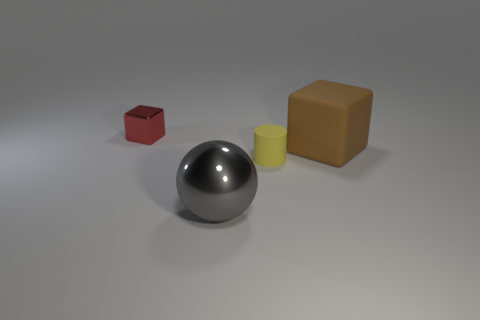Add 3 small cyan matte cylinders. How many objects exist? 7 Subtract all red blocks. How many blocks are left? 1 Subtract all cylinders. How many objects are left? 3 Add 3 big gray objects. How many big gray objects are left? 4 Add 1 blue shiny cylinders. How many blue shiny cylinders exist? 1 Subtract 0 brown cylinders. How many objects are left? 4 Subtract 2 cubes. How many cubes are left? 0 Subtract all purple spheres. Subtract all red cylinders. How many spheres are left? 1 Subtract all purple spheres. How many brown cylinders are left? 0 Subtract all small yellow objects. Subtract all large metallic things. How many objects are left? 2 